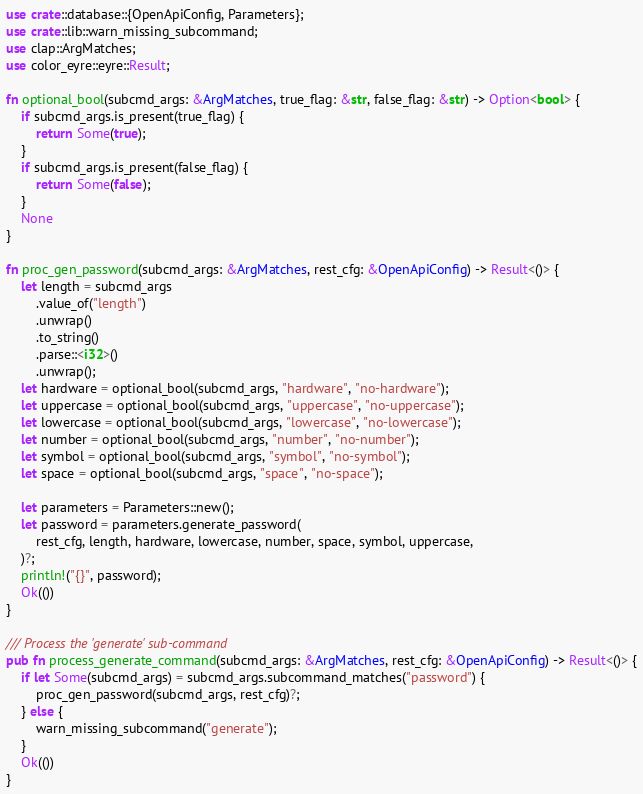Convert code to text. <code><loc_0><loc_0><loc_500><loc_500><_Rust_>use crate::database::{OpenApiConfig, Parameters};
use crate::lib::warn_missing_subcommand;
use clap::ArgMatches;
use color_eyre::eyre::Result;

fn optional_bool(subcmd_args: &ArgMatches, true_flag: &str, false_flag: &str) -> Option<bool> {
    if subcmd_args.is_present(true_flag) {
        return Some(true);
    }
    if subcmd_args.is_present(false_flag) {
        return Some(false);
    }
    None
}

fn proc_gen_password(subcmd_args: &ArgMatches, rest_cfg: &OpenApiConfig) -> Result<()> {
    let length = subcmd_args
        .value_of("length")
        .unwrap()
        .to_string()
        .parse::<i32>()
        .unwrap();
    let hardware = optional_bool(subcmd_args, "hardware", "no-hardware");
    let uppercase = optional_bool(subcmd_args, "uppercase", "no-uppercase");
    let lowercase = optional_bool(subcmd_args, "lowercase", "no-lowercase");
    let number = optional_bool(subcmd_args, "number", "no-number");
    let symbol = optional_bool(subcmd_args, "symbol", "no-symbol");
    let space = optional_bool(subcmd_args, "space", "no-space");

    let parameters = Parameters::new();
    let password = parameters.generate_password(
        rest_cfg, length, hardware, lowercase, number, space, symbol, uppercase,
    )?;
    println!("{}", password);
    Ok(())
}

/// Process the 'generate' sub-command
pub fn process_generate_command(subcmd_args: &ArgMatches, rest_cfg: &OpenApiConfig) -> Result<()> {
    if let Some(subcmd_args) = subcmd_args.subcommand_matches("password") {
        proc_gen_password(subcmd_args, rest_cfg)?;
    } else {
        warn_missing_subcommand("generate");
    }
    Ok(())
}
</code> 